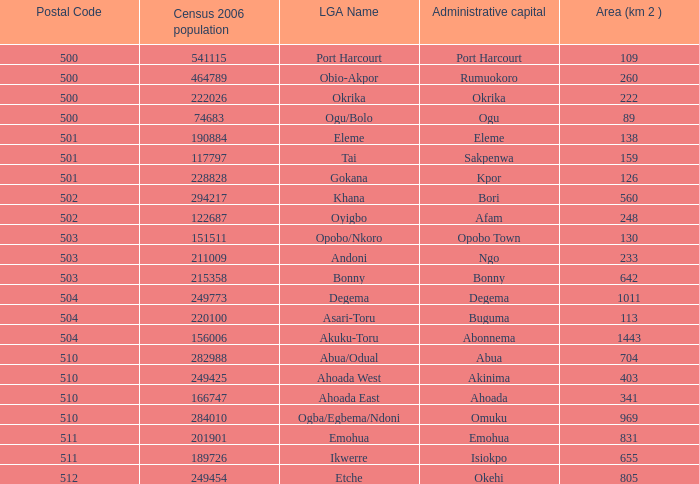What is the postal code when the administrative capital in Bori? 502.0. 